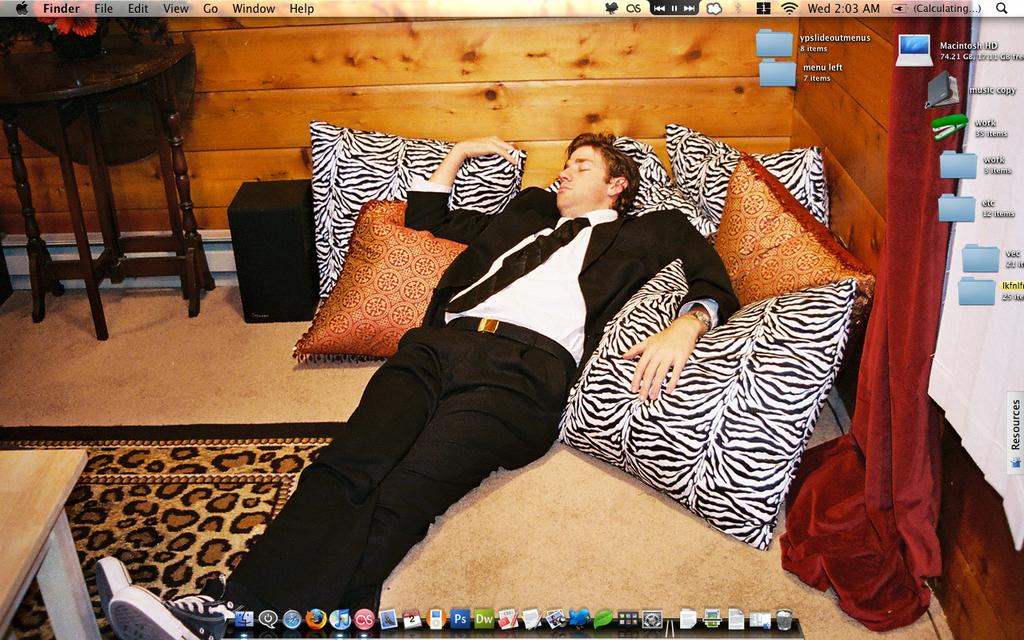What is the main subject of the image? There is a man in the image. What is the man wearing? The man is wearing a black blazer. What is the man's position in the image? The man is lying on the floor. What other objects are on the floor in the image? There are pillows, a mat, and tables on the floor. What type of image is this? The image appears to be a screen wallpaper. What type of engine can be seen in the image? There is no engine present in the image. How many matches are visible in the image? There are no matches visible in the image. 